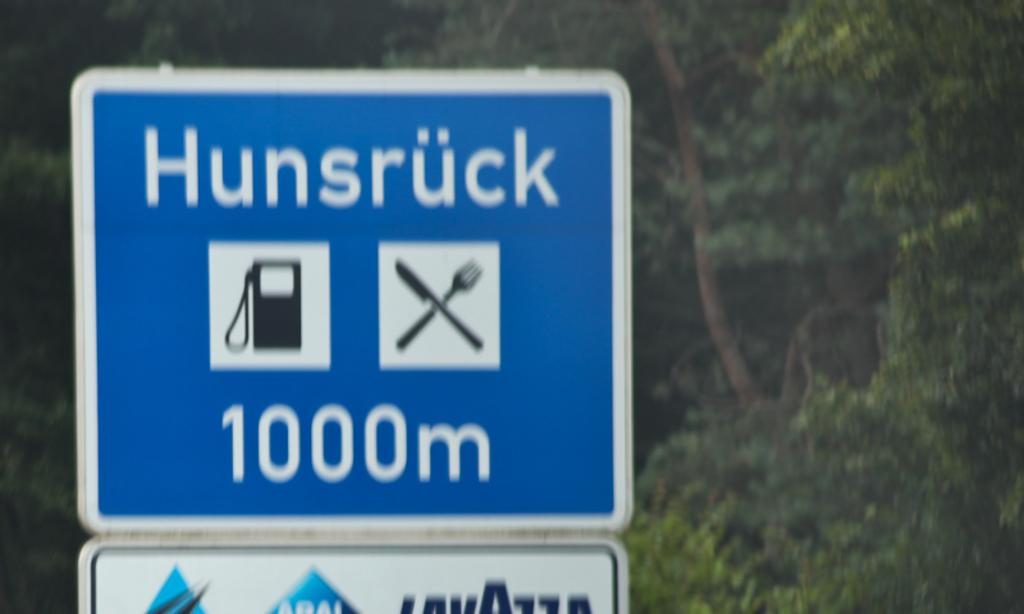What is the main object in the center of the image? There is a sign board in the center of the image. What can be seen in the background of the image? There are trees in the background of the image. What type of secretary is standing on the stage in the image? There is no secretary or stage present in the image; it only features a sign board and trees in the background. 